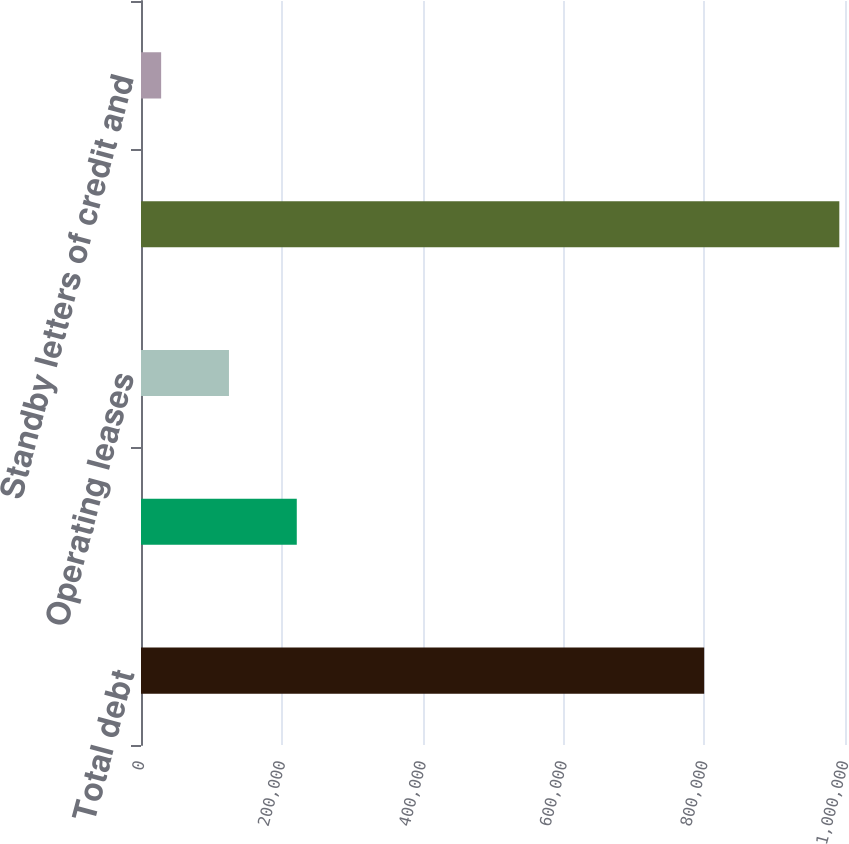<chart> <loc_0><loc_0><loc_500><loc_500><bar_chart><fcel>Total debt<fcel>Senior note interest<fcel>Operating leases<fcel>Total<fcel>Standby letters of credit and<nl><fcel>800009<fcel>221279<fcel>124946<fcel>991937<fcel>28614<nl></chart> 